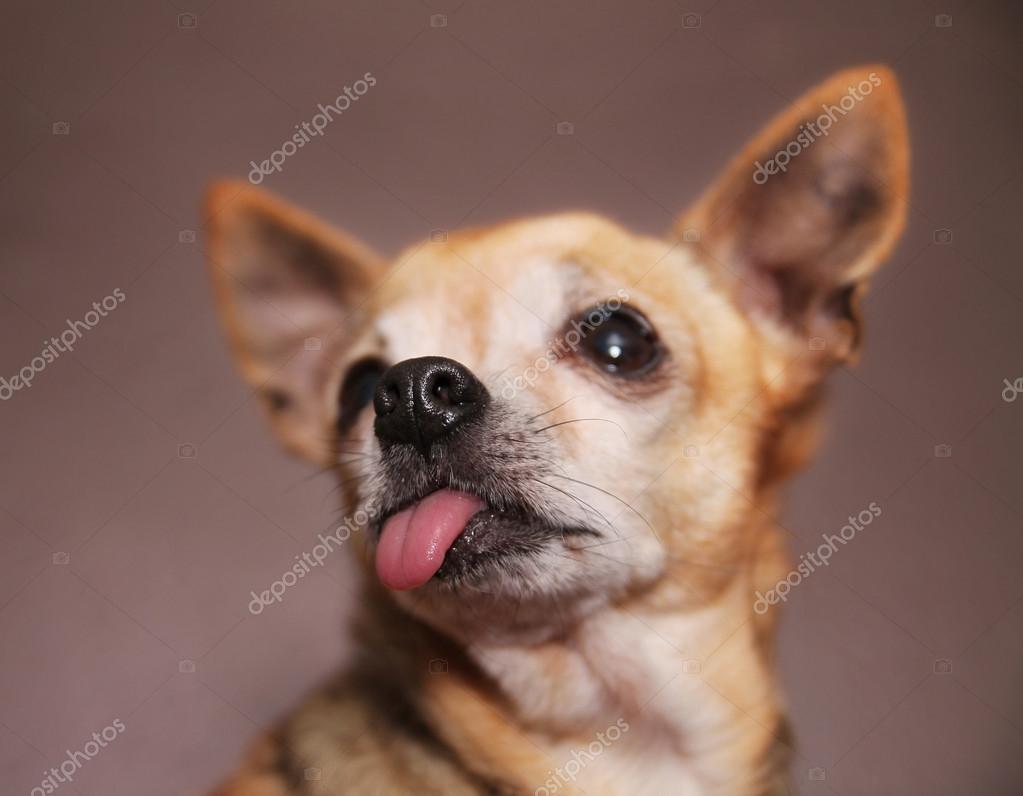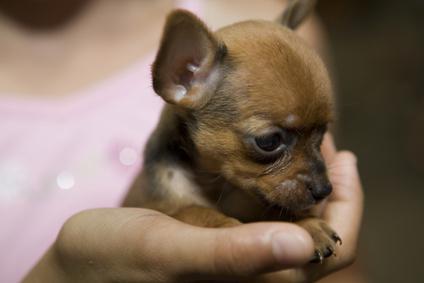The first image is the image on the left, the second image is the image on the right. Given the left and right images, does the statement "A person is holding the dog in the image on the right." hold true? Answer yes or no. Yes. The first image is the image on the left, the second image is the image on the right. For the images shown, is this caption "The dog in the image on the right is being held by a human." true? Answer yes or no. Yes. 